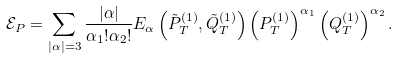<formula> <loc_0><loc_0><loc_500><loc_500>\mathcal { E } _ { P } = \sum _ { | \alpha | = 3 } \frac { | \alpha | } { \alpha _ { 1 } ! \alpha _ { 2 } ! } E _ { \alpha } \left ( \tilde { P } _ { T } ^ { ( 1 ) } , \tilde { Q } _ { T } ^ { ( 1 ) } \right ) \left ( P _ { T } ^ { ( 1 ) } \right ) ^ { \alpha _ { 1 } } \left ( Q _ { T } ^ { ( 1 ) } \right ) ^ { \alpha _ { 2 } } .</formula> 